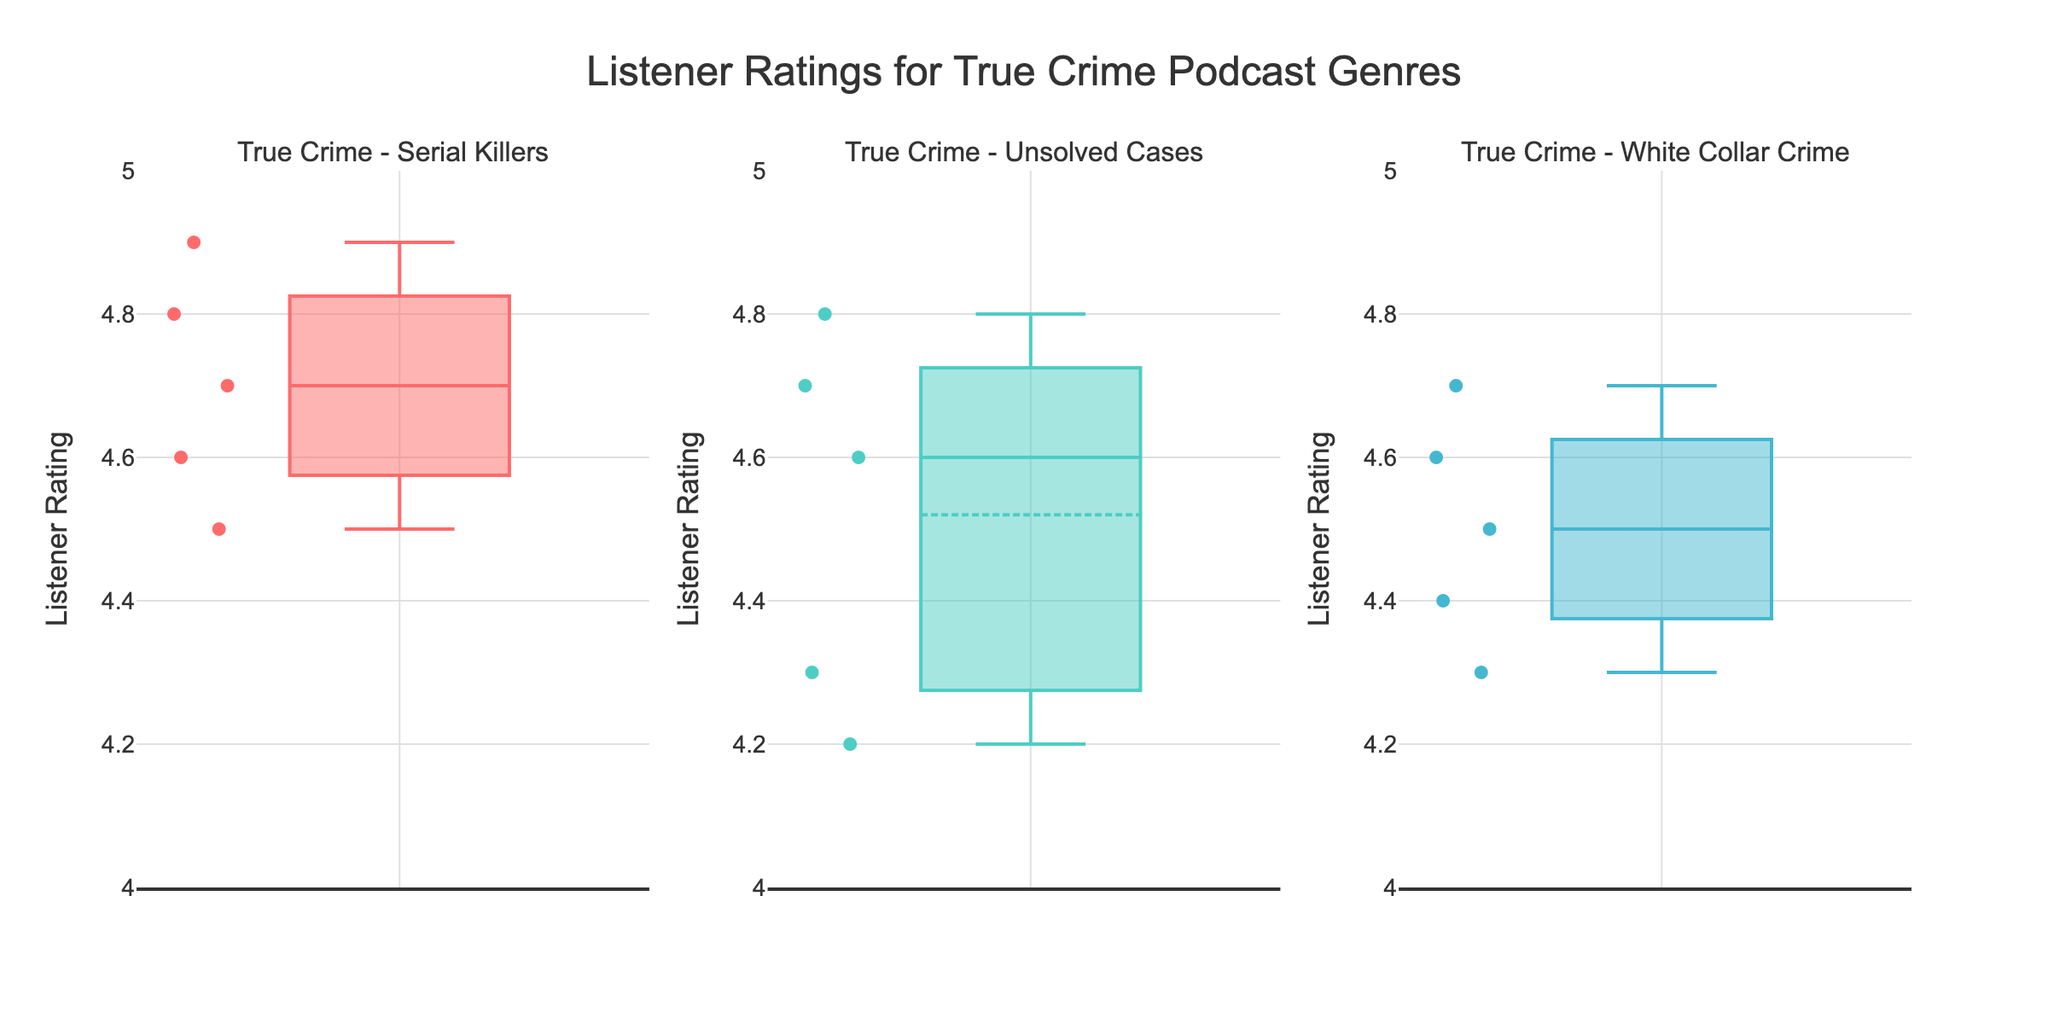What is the title of the figure? The title of the figure is displayed prominently at the top.
Answer: Listener Ratings for True Crime Podcast Genres What is the range of the y-axis for listener ratings? The y-axis is labeled with a range of values from 4 to 5, which can be seen on all three plots.
Answer: 4 to 5 How many genres of true crime podcasts are represented in the figure? Each subplot represents a different genre, and there are three subplots in total.
Answer: 3 Which genre of true crime podcasts has the highest average listener rating? The average listener rating is denoted by a line inside the box for each subplot. For "True Crime - Serial Killers", the average is around 4.7, "True Crime - Unsolved Cases" around 4.5, and "True Crime - White Collar Crime" around 4.5. "True Crime - Serial Killers" has the highest average listener rating.
Answer: True Crime - Serial Killers What is the listener rating of the podcast 'Casefile'? By examining the points on the subplot for "True Crime - Unsolved Cases", we find one of the points representing 'Casefile' at around 4.8.
Answer: 4.8 In which genre is the podcast ‘American Scandal’ and what is its rating? By examining the points on the subplot for "True Crime - White Collar Crime", we see that 'American Scandal' is rated around 4.3.
Answer: True Crime - White Collar Crime, 4.3 Which genre has the narrowest distribution of listener ratings? The width of the boxes represents the interquartile range (IQR). The subplot for "True Crime - Serial Killers" has the narrowest IQR, indicating the least variation.
Answer: True Crime - Serial Killers Compare the median listener ratings between 'True Crime - Serial Killers' and 'True Crime - White Collar Crime'. The medians are represented by the lines inside the boxes. For "True Crime - Serial Killers", the median is around 4.7, and for "True Crime - White Collar Crime", it is around 4.5.
Answer: Serial Killers (4.7) > White Collar Crime (4.5) Which true crime genre has a podcast with a listener rating of 4.9? By examining the plots, we see that in the "True Crime - Serial Killers" subplot, there is a point at 4.9.
Answer: True Crime - Serial Killers Which genre appears to have the most variability in listener ratings? Variability can be observed by the height of the boxes and the range of points. "True Crime - Unsolved Cases" has a wider box and a greater range of outliers, indicating the most variability.
Answer: True Crime - Unsolved Cases 